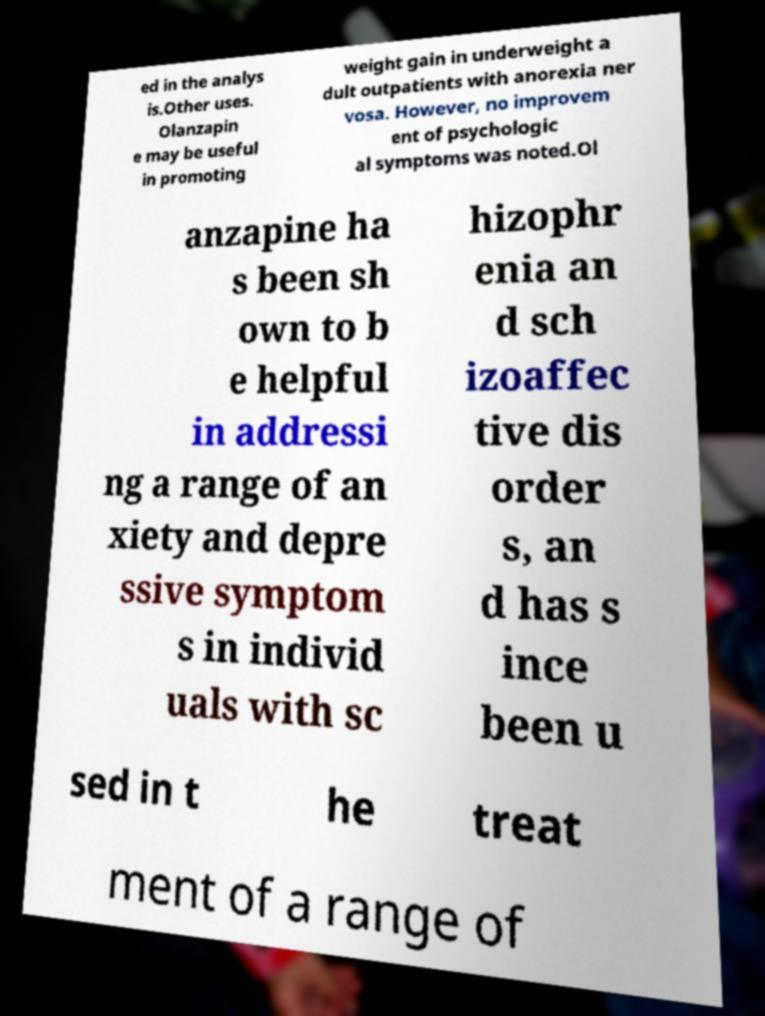There's text embedded in this image that I need extracted. Can you transcribe it verbatim? ed in the analys is.Other uses. Olanzapin e may be useful in promoting weight gain in underweight a dult outpatients with anorexia ner vosa. However, no improvem ent of psychologic al symptoms was noted.Ol anzapine ha s been sh own to b e helpful in addressi ng a range of an xiety and depre ssive symptom s in individ uals with sc hizophr enia an d sch izoaffec tive dis order s, an d has s ince been u sed in t he treat ment of a range of 